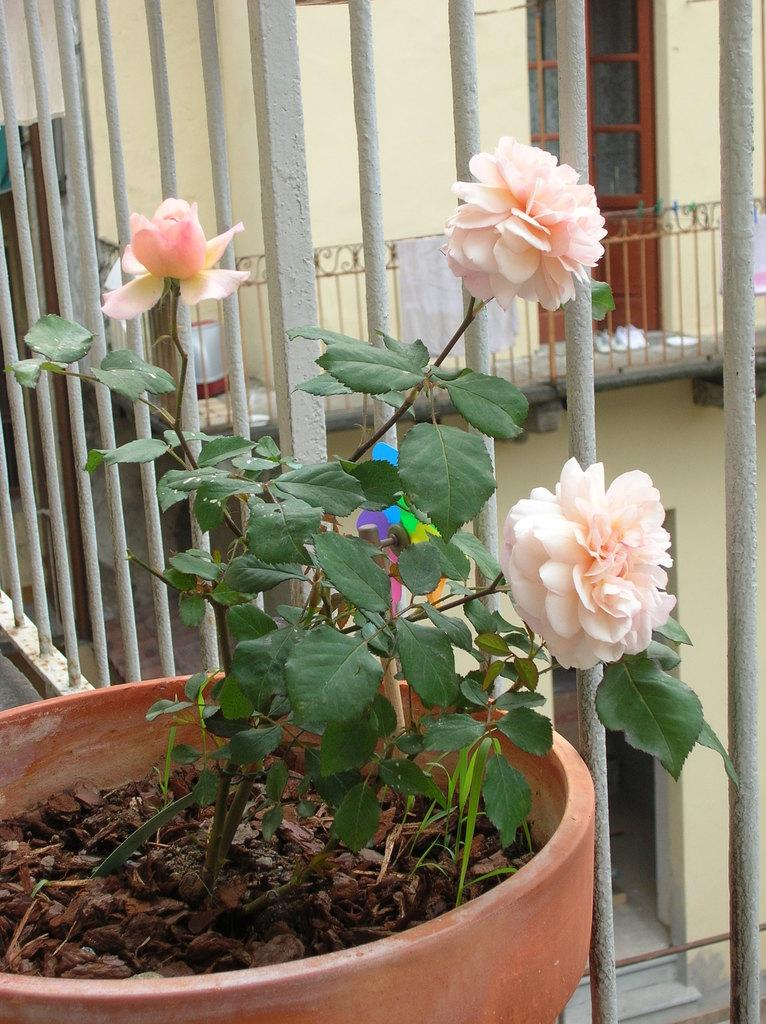What object is the main focus of the image? There is a flower pot in the image. What can be seen behind the flower pot? There are iron grills behind the flower pot. What type of structure is visible in the image has a door? There is a wall with a door in the image. Can you hear the flower pot laughing in the image? No, the flower pot does not make any sound or exhibit any human-like behavior in the image. 